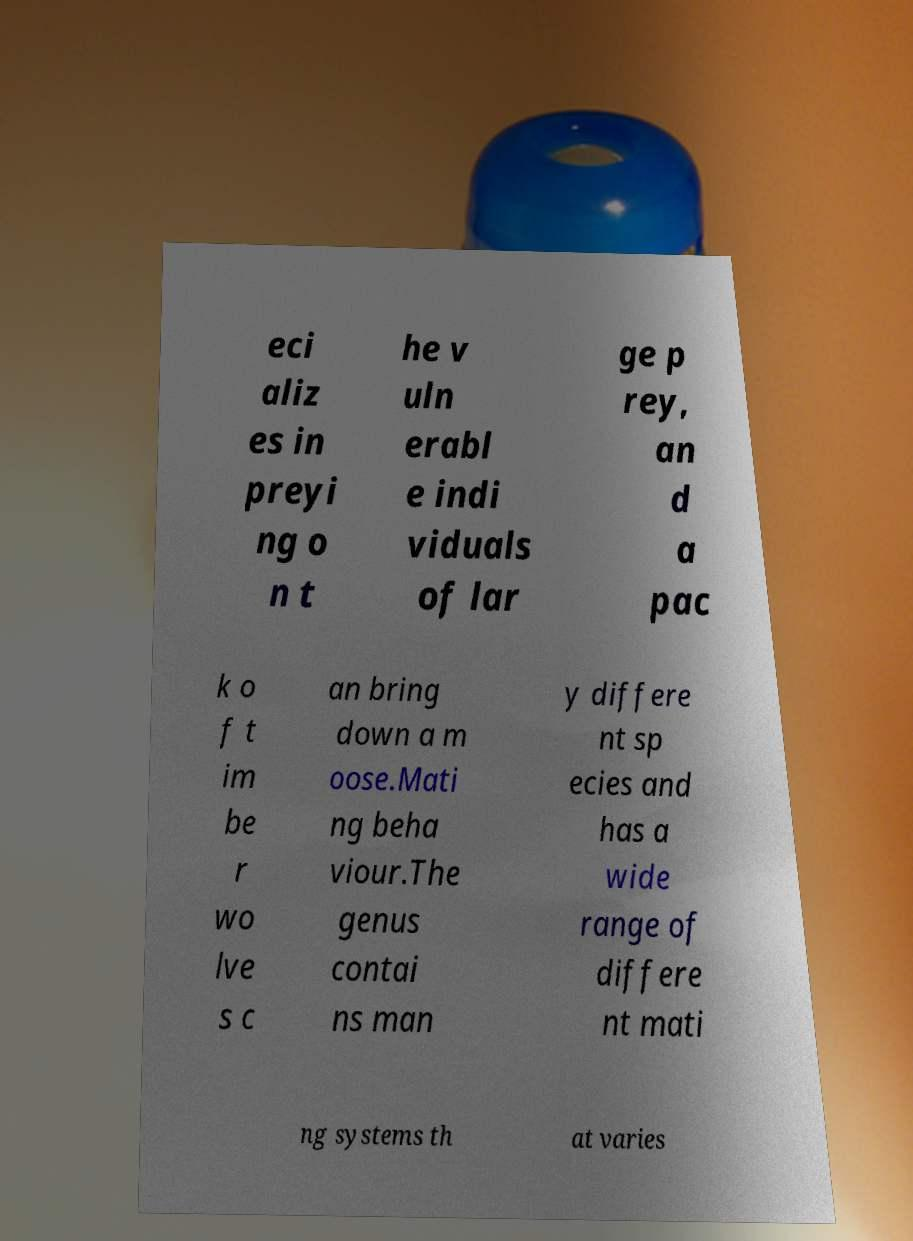There's text embedded in this image that I need extracted. Can you transcribe it verbatim? eci aliz es in preyi ng o n t he v uln erabl e indi viduals of lar ge p rey, an d a pac k o f t im be r wo lve s c an bring down a m oose.Mati ng beha viour.The genus contai ns man y differe nt sp ecies and has a wide range of differe nt mati ng systems th at varies 